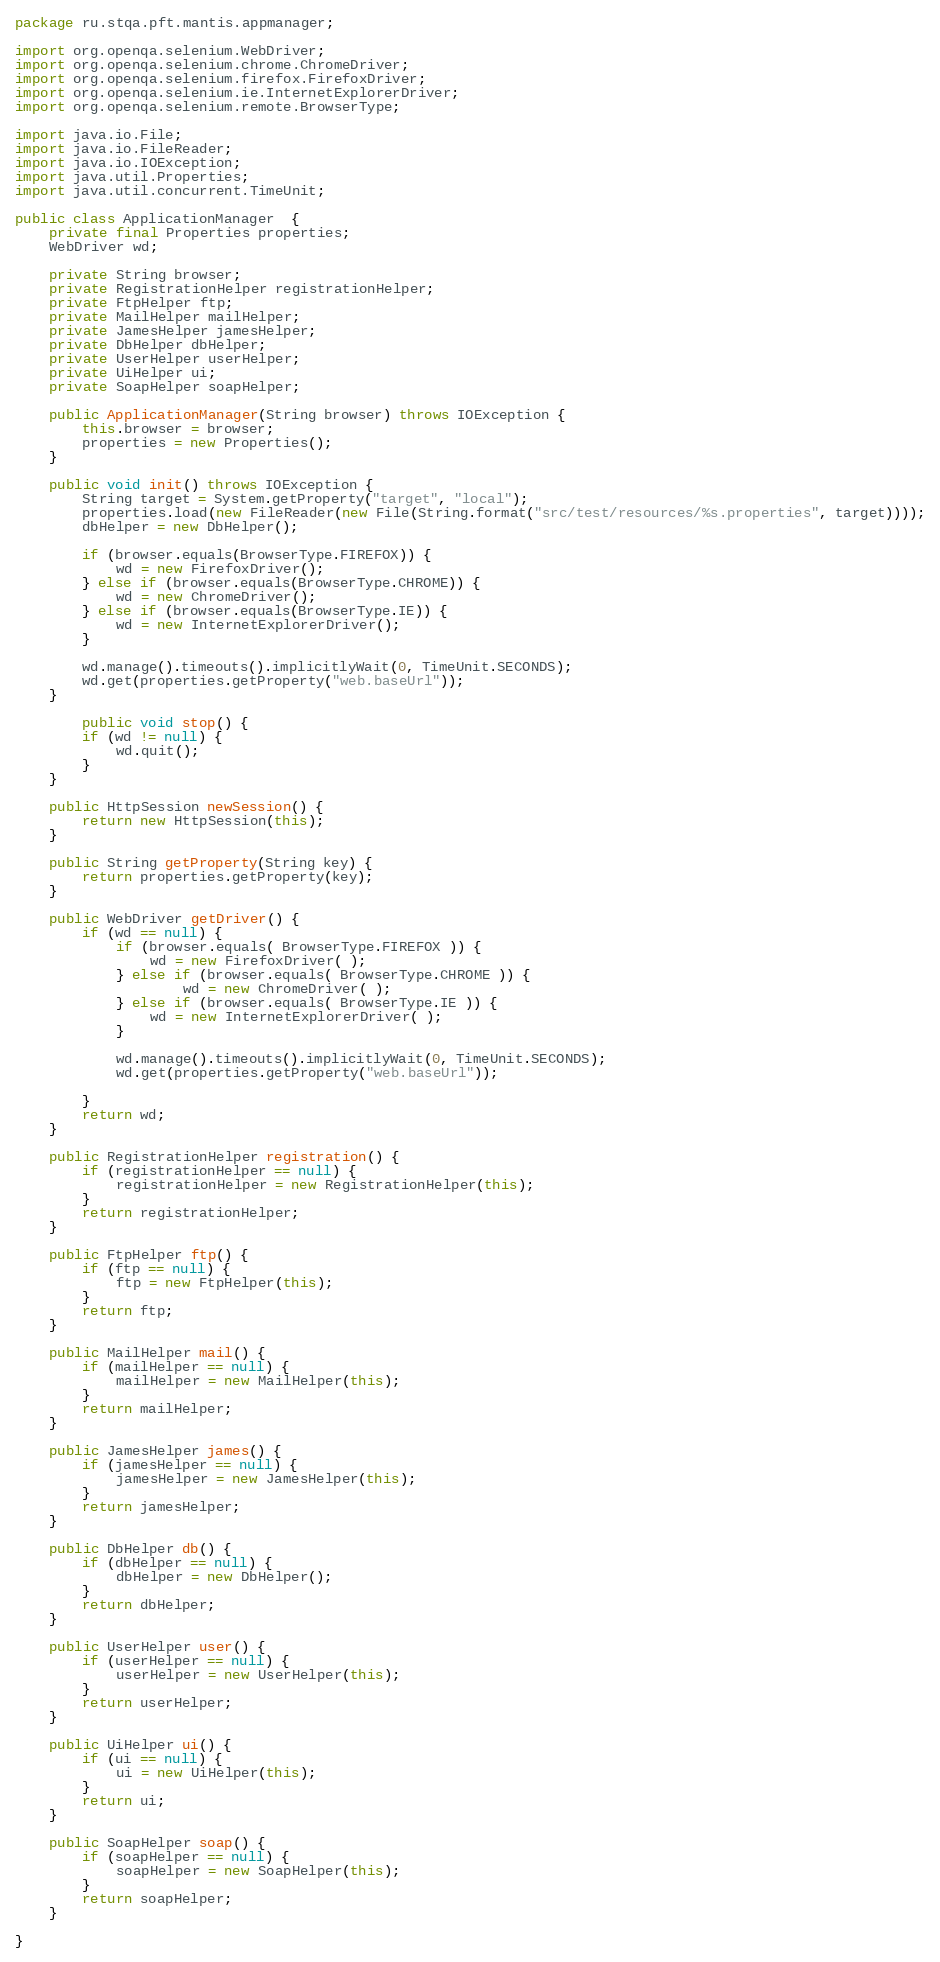<code> <loc_0><loc_0><loc_500><loc_500><_Java_>package ru.stqa.pft.mantis.appmanager;

import org.openqa.selenium.WebDriver;
import org.openqa.selenium.chrome.ChromeDriver;
import org.openqa.selenium.firefox.FirefoxDriver;
import org.openqa.selenium.ie.InternetExplorerDriver;
import org.openqa.selenium.remote.BrowserType;

import java.io.File;
import java.io.FileReader;
import java.io.IOException;
import java.util.Properties;
import java.util.concurrent.TimeUnit;

public class ApplicationManager  {
    private final Properties properties;
    WebDriver wd;

    private String browser;
    private RegistrationHelper registrationHelper;
    private FtpHelper ftp;
    private MailHelper mailHelper;
    private JamesHelper jamesHelper;
    private DbHelper dbHelper;
    private UserHelper userHelper;
    private UiHelper ui;
    private SoapHelper soapHelper;

    public ApplicationManager(String browser) throws IOException {
        this.browser = browser;
        properties = new Properties();
    }

    public void init() throws IOException {
        String target = System.getProperty("target", "local");
        properties.load(new FileReader(new File(String.format("src/test/resources/%s.properties", target))));
        dbHelper = new DbHelper();

        if (browser.equals(BrowserType.FIREFOX)) {
            wd = new FirefoxDriver();
        } else if (browser.equals(BrowserType.CHROME)) {
            wd = new ChromeDriver();
        } else if (browser.equals(BrowserType.IE)) {
            wd = new InternetExplorerDriver();
        }

        wd.manage().timeouts().implicitlyWait(0, TimeUnit.SECONDS);
        wd.get(properties.getProperty("web.baseUrl"));
    }

        public void stop() {
        if (wd != null) {
            wd.quit();
        }
    }

    public HttpSession newSession() {
        return new HttpSession(this);
    }

    public String getProperty(String key) {
        return properties.getProperty(key);
    }

    public WebDriver getDriver() {
        if (wd == null) {
            if (browser.equals( BrowserType.FIREFOX )) {
                wd = new FirefoxDriver( );
            } else if (browser.equals( BrowserType.CHROME )) {
                    wd = new ChromeDriver( );
            } else if (browser.equals( BrowserType.IE )) {
                wd = new InternetExplorerDriver( );
            }

            wd.manage().timeouts().implicitlyWait(0, TimeUnit.SECONDS);
            wd.get(properties.getProperty("web.baseUrl"));

        }
        return wd;
    }

    public RegistrationHelper registration() {
        if (registrationHelper == null) {
            registrationHelper = new RegistrationHelper(this);
        }
        return registrationHelper;
    }

    public FtpHelper ftp() {
        if (ftp == null) {
            ftp = new FtpHelper(this);
        }
        return ftp;
    }

    public MailHelper mail() {
        if (mailHelper == null) {
            mailHelper = new MailHelper(this);
        }
        return mailHelper;
    }

    public JamesHelper james() {
        if (jamesHelper == null) {
            jamesHelper = new JamesHelper(this);
        }
        return jamesHelper;
    }

    public DbHelper db() {
        if (dbHelper == null) {
            dbHelper = new DbHelper();
        }
        return dbHelper;
    }

    public UserHelper user() {
        if (userHelper == null) {
            userHelper = new UserHelper(this);
        }
        return userHelper;
    }

    public UiHelper ui() {
        if (ui == null) {
            ui = new UiHelper(this);
        }
        return ui;
    }

    public SoapHelper soap() {
        if (soapHelper == null) {
            soapHelper = new SoapHelper(this);
        }
        return soapHelper;
    }

}
</code> 